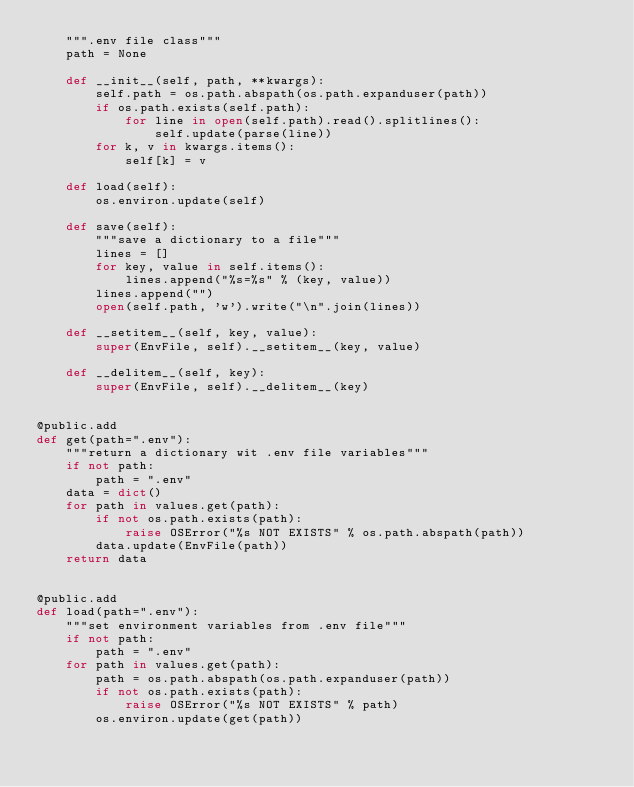<code> <loc_0><loc_0><loc_500><loc_500><_Python_>    """.env file class"""
    path = None

    def __init__(self, path, **kwargs):
        self.path = os.path.abspath(os.path.expanduser(path))
        if os.path.exists(self.path):
            for line in open(self.path).read().splitlines():
                self.update(parse(line))
        for k, v in kwargs.items():
            self[k] = v

    def load(self):
        os.environ.update(self)

    def save(self):
        """save a dictionary to a file"""
        lines = []
        for key, value in self.items():
            lines.append("%s=%s" % (key, value))
        lines.append("")
        open(self.path, 'w').write("\n".join(lines))

    def __setitem__(self, key, value):
        super(EnvFile, self).__setitem__(key, value)

    def __delitem__(self, key):
        super(EnvFile, self).__delitem__(key)


@public.add
def get(path=".env"):
    """return a dictionary wit .env file variables"""
    if not path:
        path = ".env"
    data = dict()
    for path in values.get(path):
        if not os.path.exists(path):
            raise OSError("%s NOT EXISTS" % os.path.abspath(path))
        data.update(EnvFile(path))
    return data


@public.add
def load(path=".env"):
    """set environment variables from .env file"""
    if not path:
        path = ".env"
    for path in values.get(path):
        path = os.path.abspath(os.path.expanduser(path))
        if not os.path.exists(path):
            raise OSError("%s NOT EXISTS" % path)
        os.environ.update(get(path))
</code> 